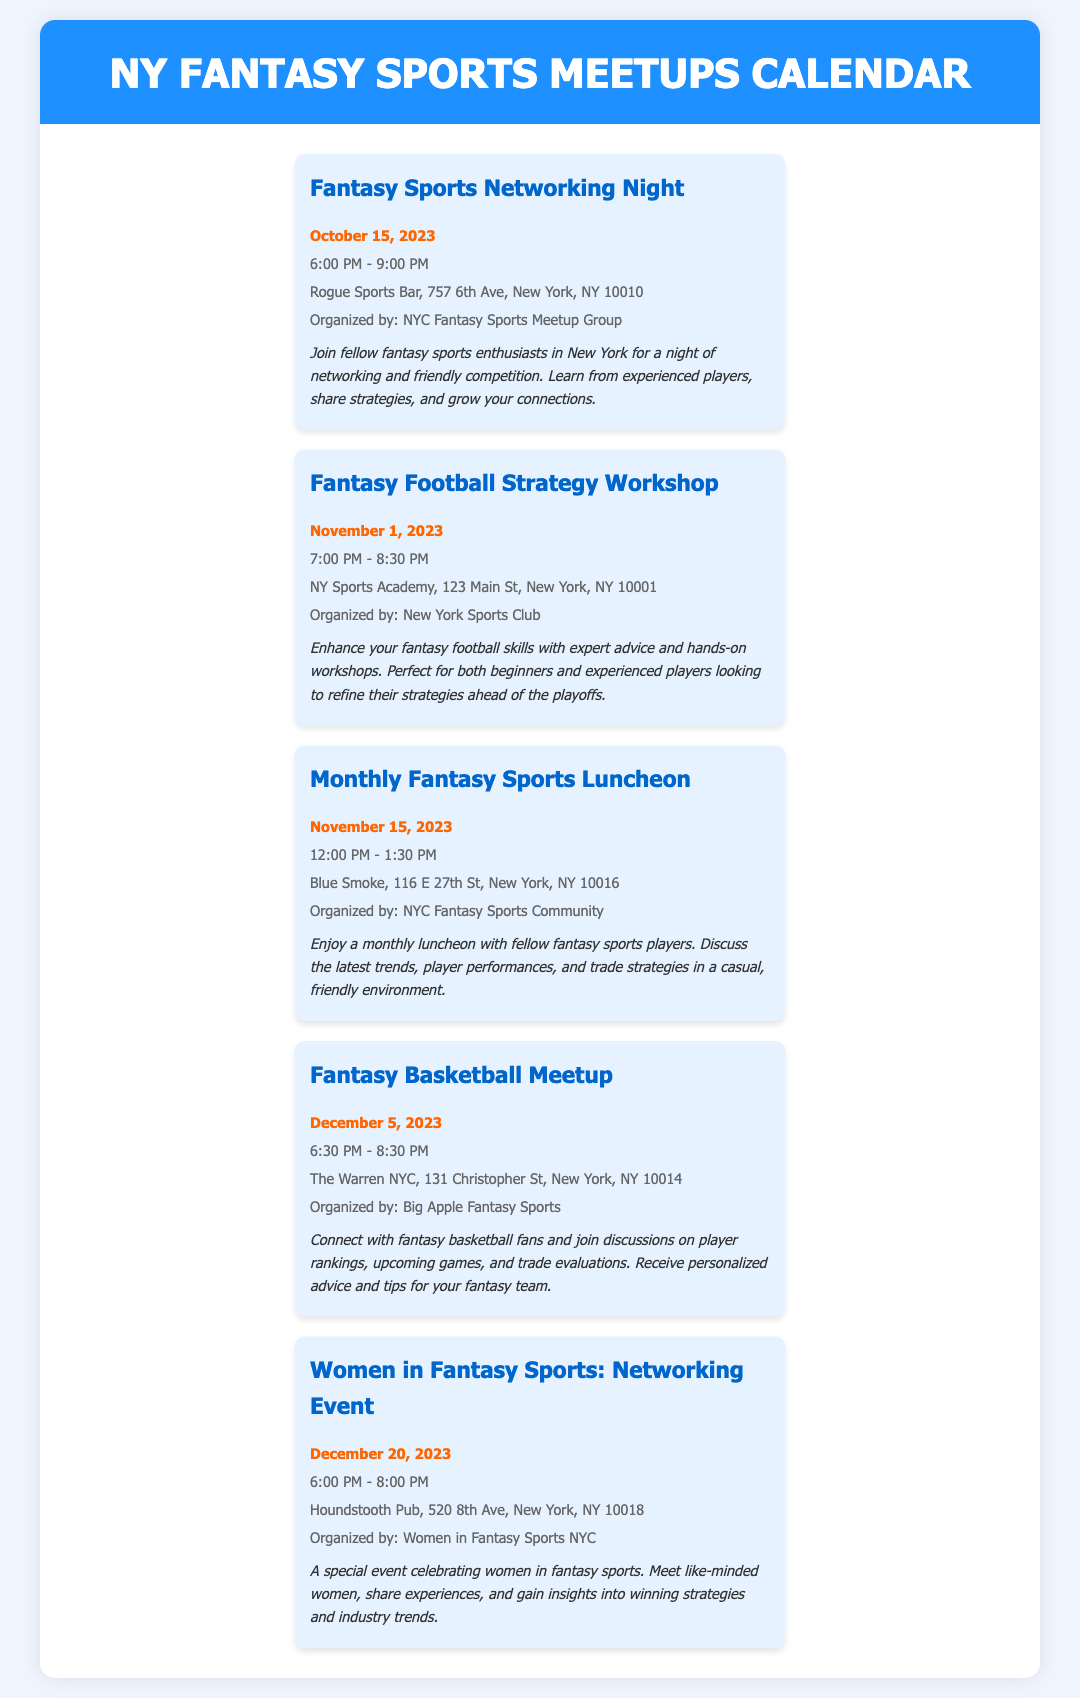What is the date of the Fantasy Sports Networking Night? The date is provided in the event details for the Fantasy Sports Networking Night.
Answer: October 15, 2023 Where is the Fantasy Football Strategy Workshop taking place? The location is specified in the event details for the Fantasy Football Strategy Workshop.
Answer: NY Sports Academy, 123 Main St, New York, NY 10001 Who is organizing the Monthly Fantasy Sports Luncheon? The organizer is mentioned in the event details for the Monthly Fantasy Sports Luncheon.
Answer: NYC Fantasy Sports Community What time does the Fantasy Basketball Meetup start? The start time is included in the event information for the Fantasy Basketball Meetup.
Answer: 6:30 PM How many events are listed in the calendar? The number of events can be counted from the document.
Answer: 5 What is the theme of the event on December 20, 2023? The theme is described in the event details for the December 20 event.
Answer: Women in Fantasy Sports What is the duration of the Fantasy Sports Networking Night? The duration is stated in the time information for the Fantasy Sports Networking Night.
Answer: 3 hours Which event has the latest date? The latest date is determined by comparing the event dates.
Answer: Women in Fantasy Sports: Networking Event What type of event is scheduled for November 1, 2023? The type of event is characterized in the title and description for the November 1 event.
Answer: Workshop 